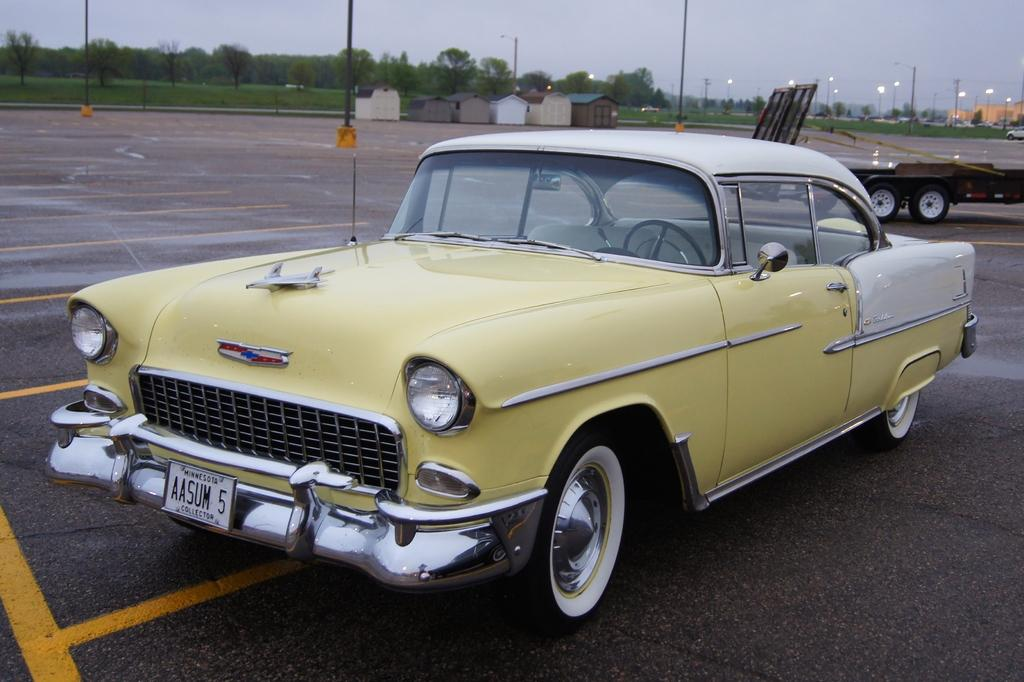What is the main subject of the image? There is a car on the road in the image. Are there any other vehicles in the image? Yes, there are other vehicles behind the car. What can be seen in the background of the image? Poles, grass, trees, and a building are visible in the image. What type of shoe can be seen hanging from the pole in the image? There is no shoe present in the image; only poles, grass, trees, and a building are visible. 